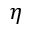Convert formula to latex. <formula><loc_0><loc_0><loc_500><loc_500>\eta</formula> 